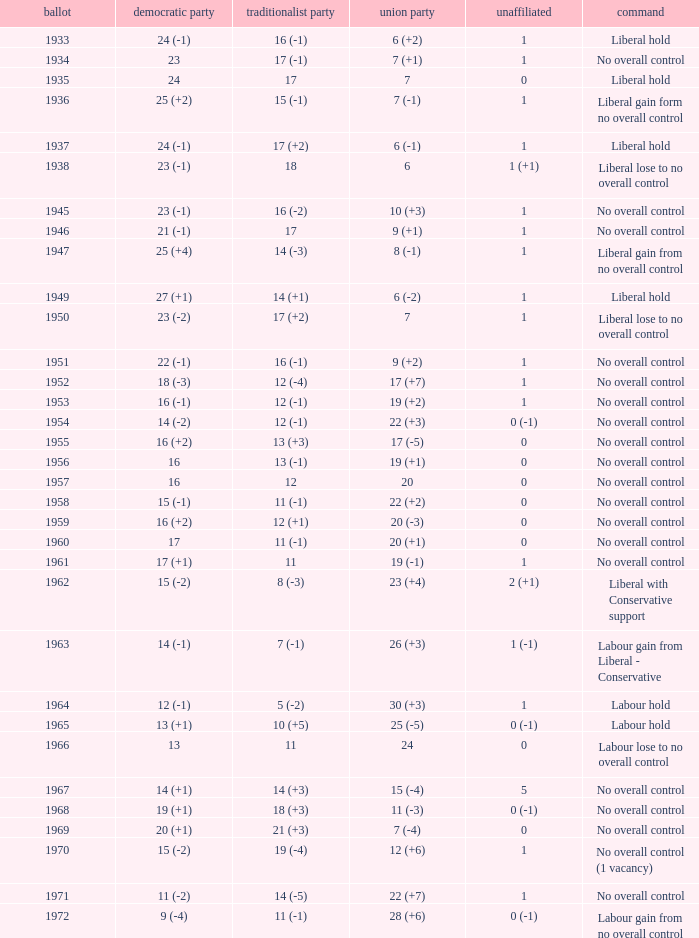What is the number of Independents elected in the year Labour won 26 (+3) seats? 1 (-1). Can you give me this table as a dict? {'header': ['ballot', 'democratic party', 'traditionalist party', 'union party', 'unaffiliated', 'command'], 'rows': [['1933', '24 (-1)', '16 (-1)', '6 (+2)', '1', 'Liberal hold'], ['1934', '23', '17 (-1)', '7 (+1)', '1', 'No overall control'], ['1935', '24', '17', '7', '0', 'Liberal hold'], ['1936', '25 (+2)', '15 (-1)', '7 (-1)', '1', 'Liberal gain form no overall control'], ['1937', '24 (-1)', '17 (+2)', '6 (-1)', '1', 'Liberal hold'], ['1938', '23 (-1)', '18', '6', '1 (+1)', 'Liberal lose to no overall control'], ['1945', '23 (-1)', '16 (-2)', '10 (+3)', '1', 'No overall control'], ['1946', '21 (-1)', '17', '9 (+1)', '1', 'No overall control'], ['1947', '25 (+4)', '14 (-3)', '8 (-1)', '1', 'Liberal gain from no overall control'], ['1949', '27 (+1)', '14 (+1)', '6 (-2)', '1', 'Liberal hold'], ['1950', '23 (-2)', '17 (+2)', '7', '1', 'Liberal lose to no overall control'], ['1951', '22 (-1)', '16 (-1)', '9 (+2)', '1', 'No overall control'], ['1952', '18 (-3)', '12 (-4)', '17 (+7)', '1', 'No overall control'], ['1953', '16 (-1)', '12 (-1)', '19 (+2)', '1', 'No overall control'], ['1954', '14 (-2)', '12 (-1)', '22 (+3)', '0 (-1)', 'No overall control'], ['1955', '16 (+2)', '13 (+3)', '17 (-5)', '0', 'No overall control'], ['1956', '16', '13 (-1)', '19 (+1)', '0', 'No overall control'], ['1957', '16', '12', '20', '0', 'No overall control'], ['1958', '15 (-1)', '11 (-1)', '22 (+2)', '0', 'No overall control'], ['1959', '16 (+2)', '12 (+1)', '20 (-3)', '0', 'No overall control'], ['1960', '17', '11 (-1)', '20 (+1)', '0', 'No overall control'], ['1961', '17 (+1)', '11', '19 (-1)', '1', 'No overall control'], ['1962', '15 (-2)', '8 (-3)', '23 (+4)', '2 (+1)', 'Liberal with Conservative support'], ['1963', '14 (-1)', '7 (-1)', '26 (+3)', '1 (-1)', 'Labour gain from Liberal - Conservative'], ['1964', '12 (-1)', '5 (-2)', '30 (+3)', '1', 'Labour hold'], ['1965', '13 (+1)', '10 (+5)', '25 (-5)', '0 (-1)', 'Labour hold'], ['1966', '13', '11', '24', '0', 'Labour lose to no overall control'], ['1967', '14 (+1)', '14 (+3)', '15 (-4)', '5', 'No overall control'], ['1968', '19 (+1)', '18 (+3)', '11 (-3)', '0 (-1)', 'No overall control'], ['1969', '20 (+1)', '21 (+3)', '7 (-4)', '0', 'No overall control'], ['1970', '15 (-2)', '19 (-4)', '12 (+6)', '1', 'No overall control (1 vacancy)'], ['1971', '11 (-2)', '14 (-5)', '22 (+7)', '1', 'No overall control'], ['1972', '9 (-4)', '11 (-1)', '28 (+6)', '0 (-1)', 'Labour gain from no overall control']]} 